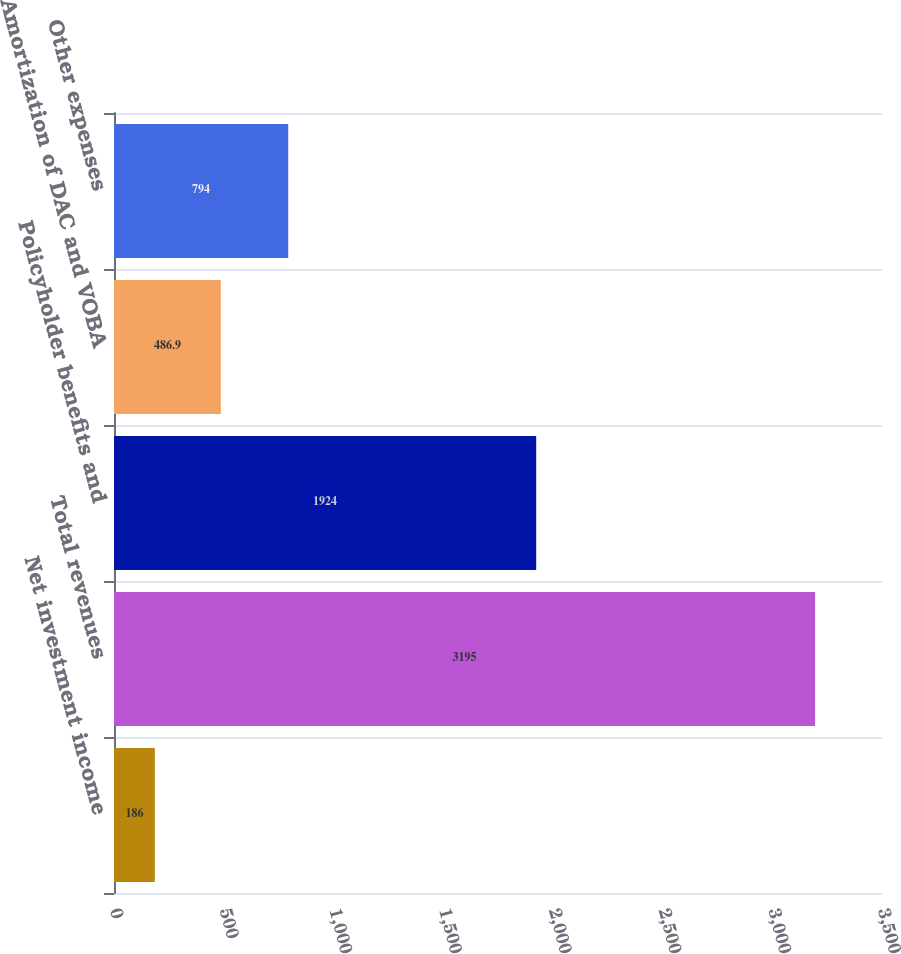Convert chart to OTSL. <chart><loc_0><loc_0><loc_500><loc_500><bar_chart><fcel>Net investment income<fcel>Total revenues<fcel>Policyholder benefits and<fcel>Amortization of DAC and VOBA<fcel>Other expenses<nl><fcel>186<fcel>3195<fcel>1924<fcel>486.9<fcel>794<nl></chart> 